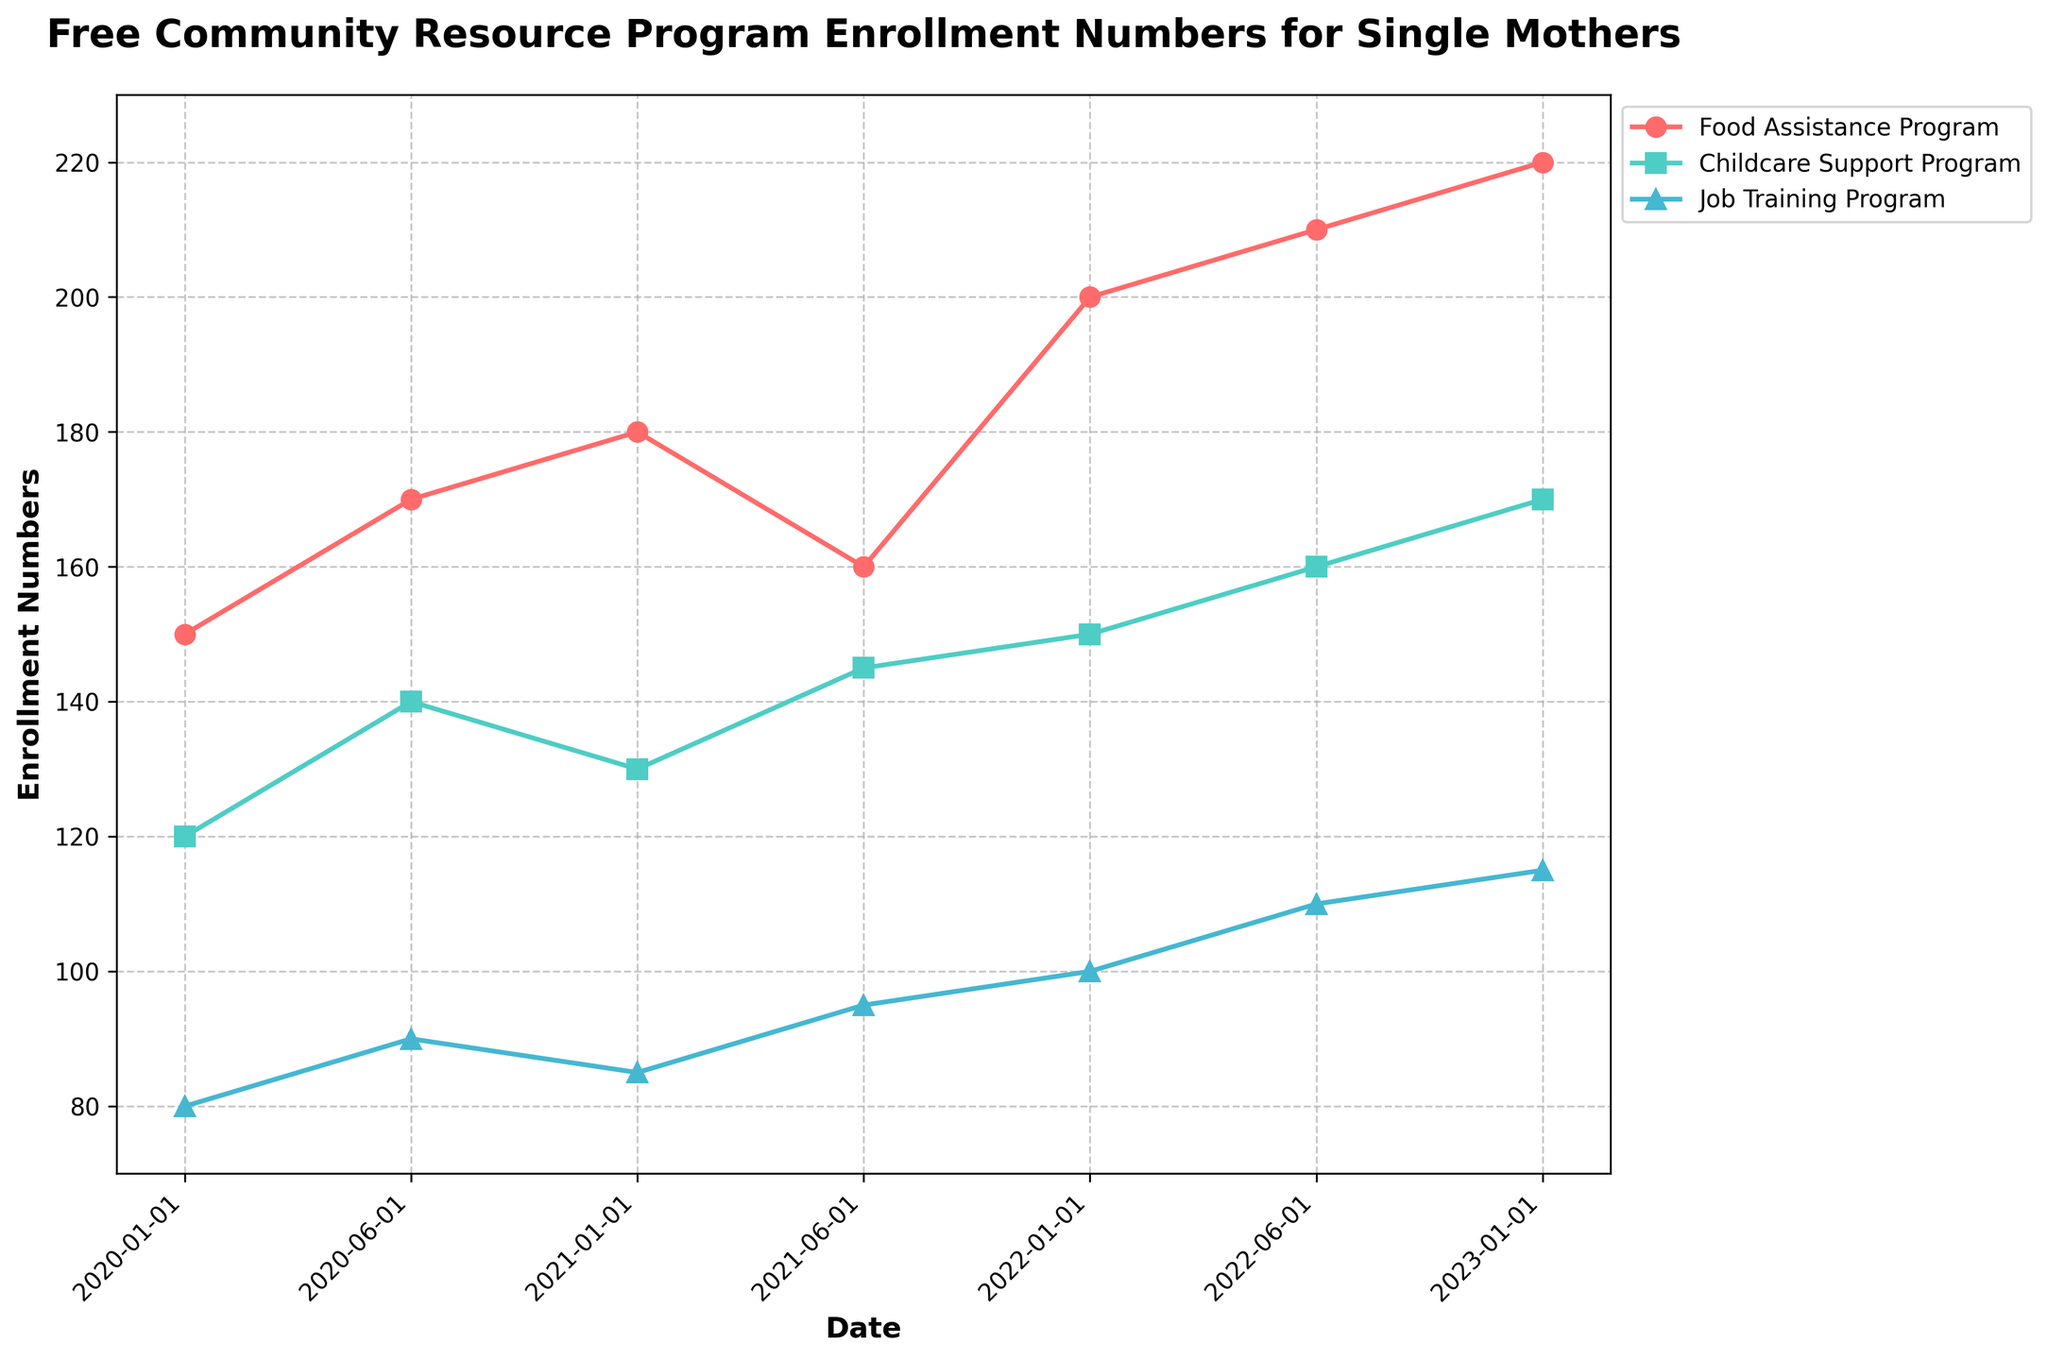How many programs are shown in the time series plot? There are three distinct programs shown in the plot, each represented by a different color and marker. These programs are Food Assistance Program, Childcare Support Program, and Job Training Program.
Answer: Three What is the title of the figure? The title is written at the top of the figure and reads "Free Community Resource Program Enrollment Numbers for Single Mothers."
Answer: Free Community Resource Program Enrollment Numbers for Single Mothers Which program had the highest enrollment in January 2022? The plot shows three lines, each representing a different program. The line corresponding to January 2022 shows the highest enrollment number for the Food Assistance Program at 200.
Answer: Food Assistance Program What is the trend in the enrollment numbers for the Food Assistance Program from January 2020 to January 2023? Observing the line for the Food Assistance Program, which is in a specific color and marker, we can see a general upward trend from 150 in January 2020 to 220 in January 2023.
Answer: Upward Compare the enrollment numbers for the Childcare Support Program in June 2020 and June 2021. Which one is higher? By comparing the points on the Childcare Support Program line, the number in June 2020 is 140, and in June 2021, it is 145. Thus, June 2021 has higher enrollment.
Answer: June 2021 What is the average enrollment number for the Job Training Program over the period shown? The Job Training Program has enrollment numbers at six different points: 80, 90, 85, 95, 100, 110, and 115. Calculating the average [ (80+90+85+95+100+110+115)/7 ] gives approximately 96.43.
Answer: 96.43 Did any programs show a decrease in enrollment between any two time points? Observing each program's line, the Food Assistance Program shows a decrease from 180 in January 2021 to 160 in June 2021.
Answer: Yes How much did the enrollment for the Childcare Support Program increase from January 2020 to January 2023? The enrollment number for the Childcare Support Program in January 2020 was 120, and it increased to 170 by January 2023. The difference is 170 - 120 = 50.
Answer: 50 Between January 2022 and June 2022, which program saw the highest increase in enrollment numbers? Calculate the difference for each program: Food Assistance Program (210 - 200 = 10), Childcare Support Program (160 - 150 = 10), and Job Training Program (110 - 100 = 10). All programs had the same increase of 10.
Answer: All programs Which program shows a steady increase in enrollment every six months over the period shown? Observing the trends for each program, the Job Training Program shows a steady increase in enrollment numbers at every six-month interval between January 2020 and January 2023.
Answer: Job Training Program 